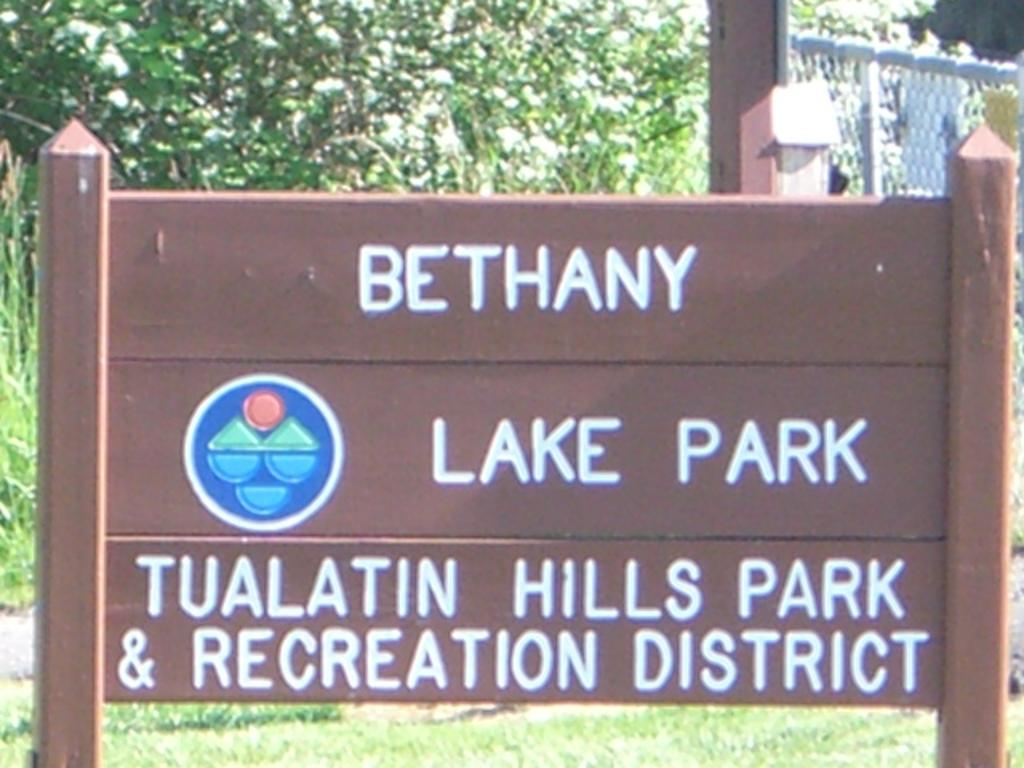What is present on the ground in the image? There is a hoarding on the ground in the image. What can be read on the hoarding? The hoarding has the text "Lake Park" written on it. What type of surface is the hoarding placed on? The ground is covered with grass. What can be seen in the background of the image? There are trees visible in the background. What type of bun is being used to hold the story on the hoarding? There is: There is no bun or story present on the hoarding in the image; it only has the text "Lake Park" written on it. How many cabbages are visible in the image? There are no cabbages present in the image. 